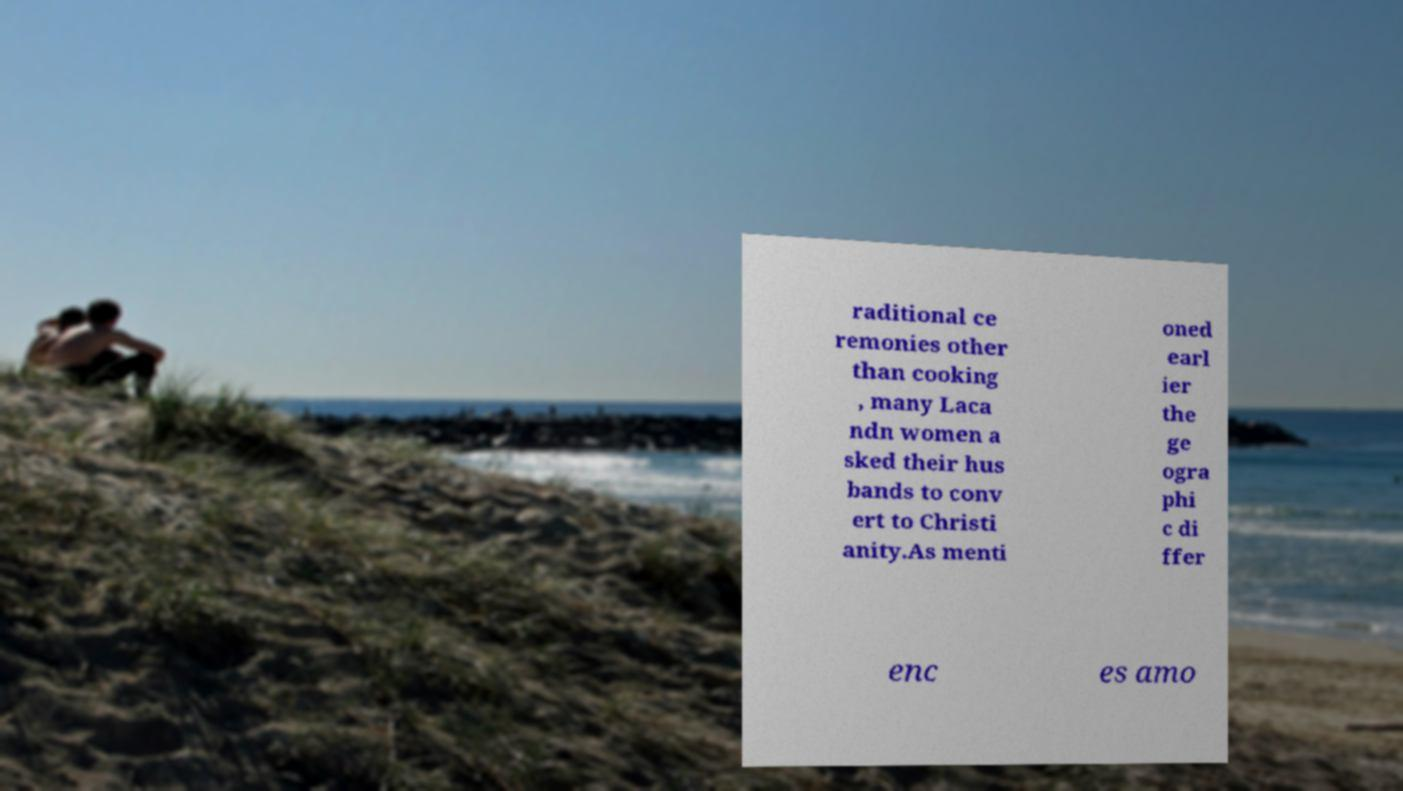Can you accurately transcribe the text from the provided image for me? raditional ce remonies other than cooking , many Laca ndn women a sked their hus bands to conv ert to Christi anity.As menti oned earl ier the ge ogra phi c di ffer enc es amo 